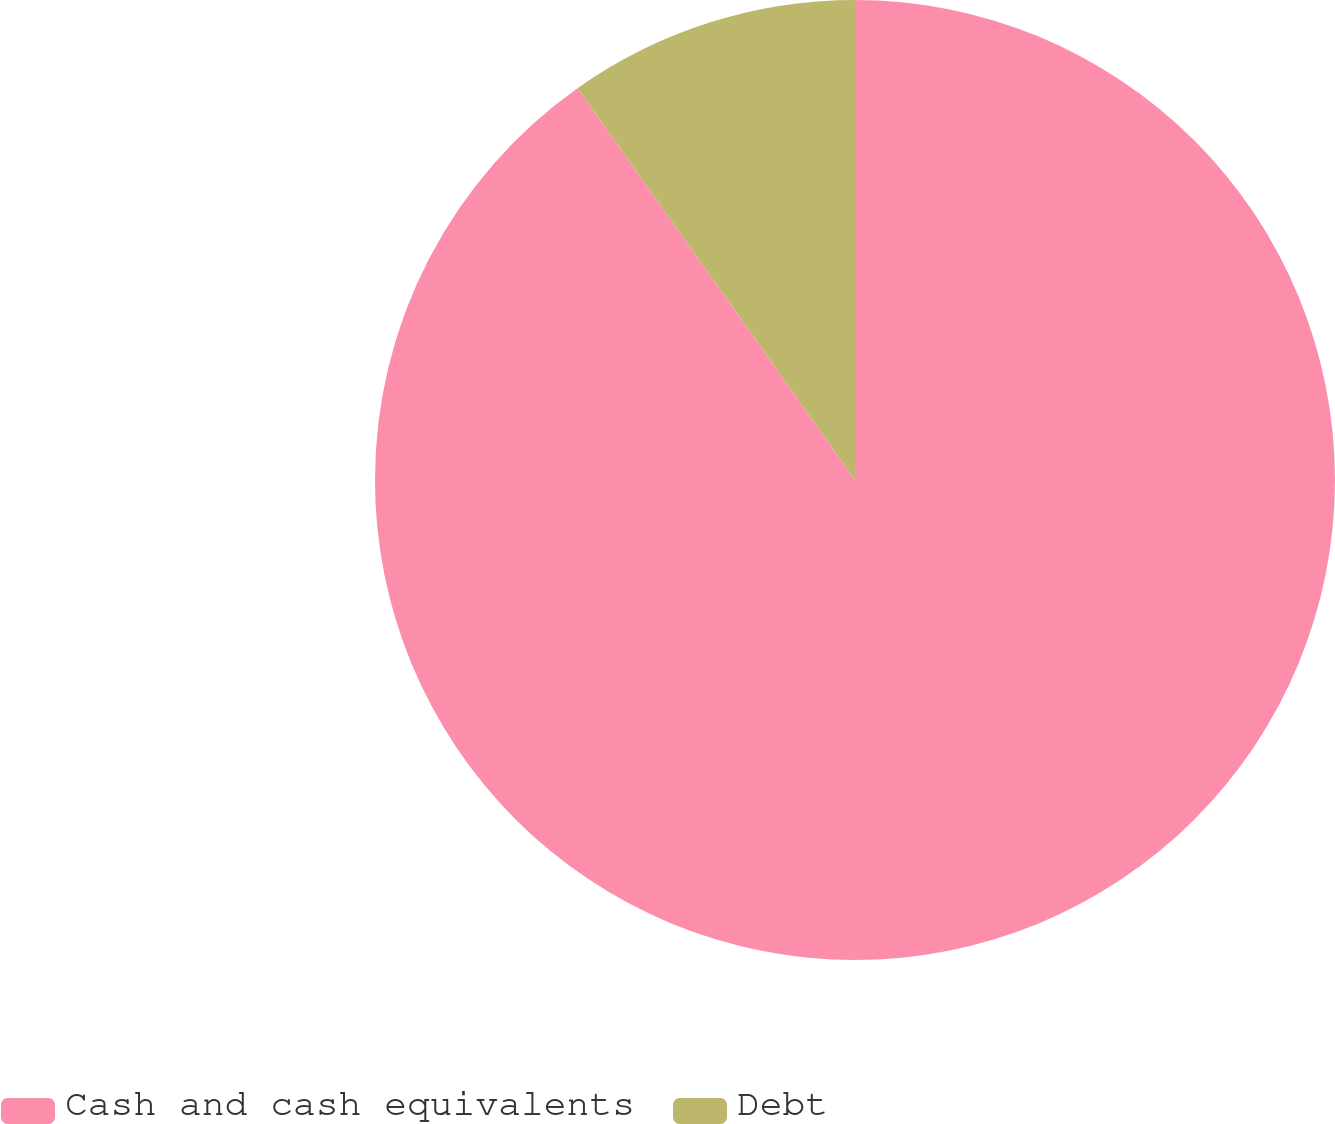Convert chart. <chart><loc_0><loc_0><loc_500><loc_500><pie_chart><fcel>Cash and cash equivalents<fcel>Debt<nl><fcel>90.19%<fcel>9.81%<nl></chart> 